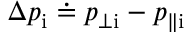<formula> <loc_0><loc_0><loc_500><loc_500>\Delta p _ { i } \doteq p _ { \perp i } - p _ { \| i }</formula> 